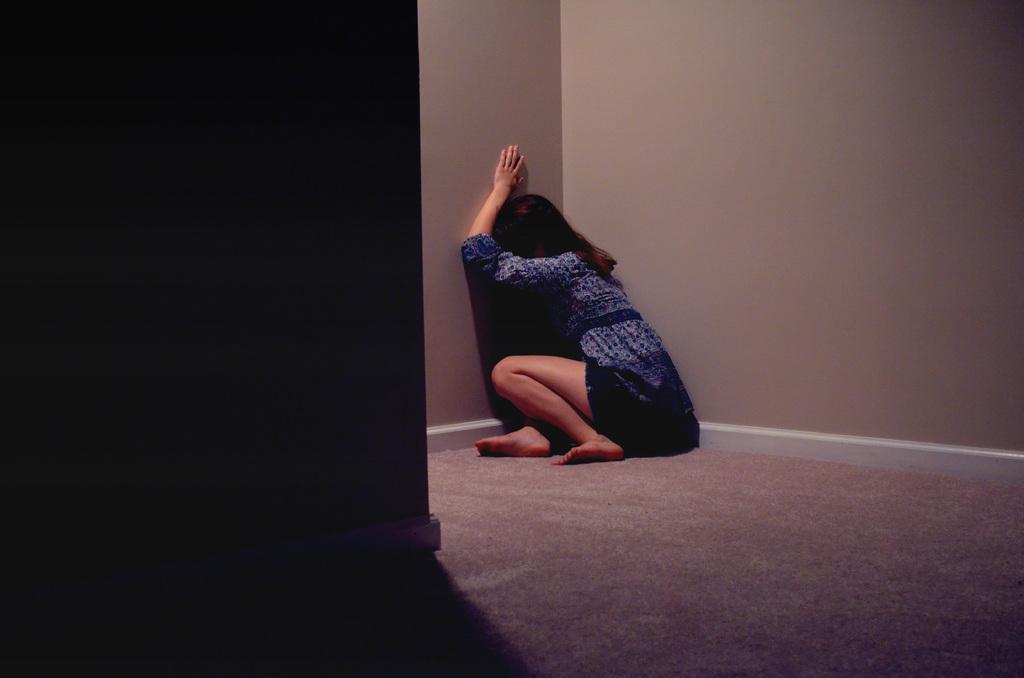How would you summarize this image in a sentence or two? In this picture I can see a woman seated on the floor and I can see carpet on the floor and I can see walls. 